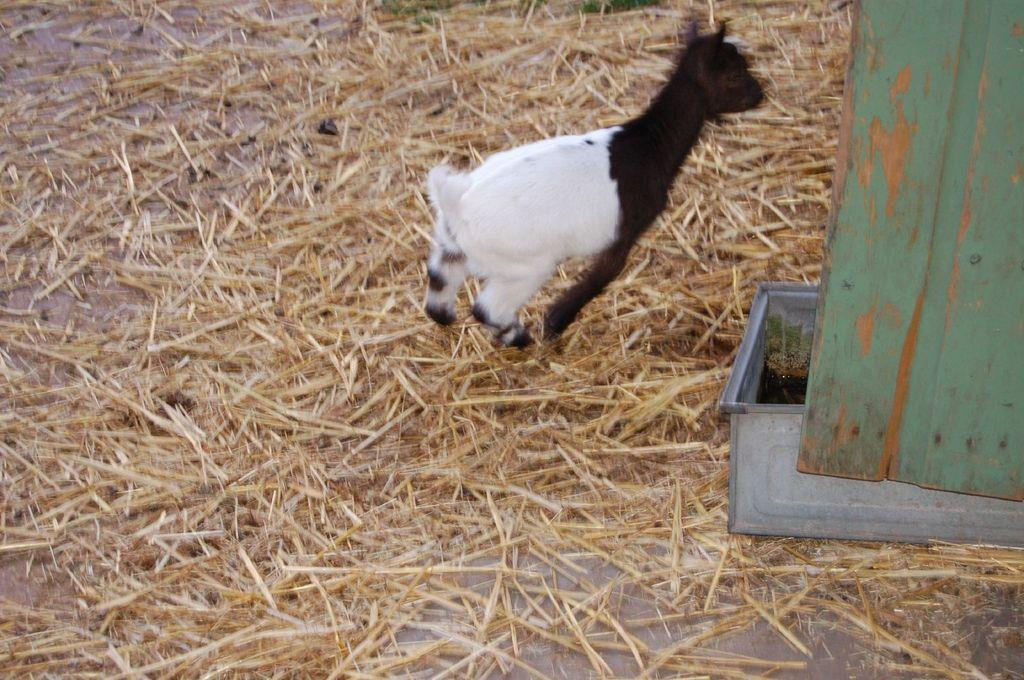What animal is present in the image? There is a goat in the image. What is the goat standing on? The goat is on dried grass. Can you locate the container with water in the image? The container with water is on the right side of the image. What other object can be seen in the image? There is a wooden board in the image. What time of day is it in the image, and how does the goat feel about the morning? The time of day is not mentioned in the image, and there is no indication of the goat's feelings about the morning. What type of bottle is being used as a prop in the image? There is no bottle present in the image. 